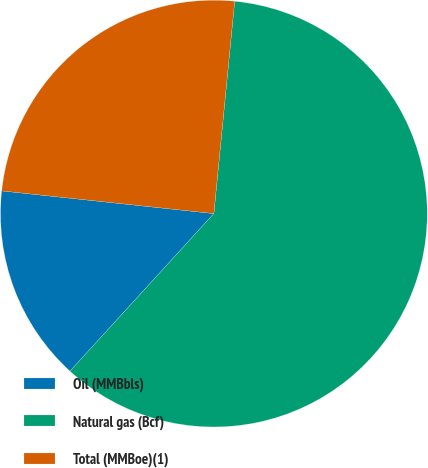Convert chart. <chart><loc_0><loc_0><loc_500><loc_500><pie_chart><fcel>Oil (MMBbls)<fcel>Natural gas (Bcf)<fcel>Total (MMBoe)(1)<nl><fcel>14.92%<fcel>60.22%<fcel>24.86%<nl></chart> 